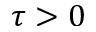Convert formula to latex. <formula><loc_0><loc_0><loc_500><loc_500>\tau > 0</formula> 